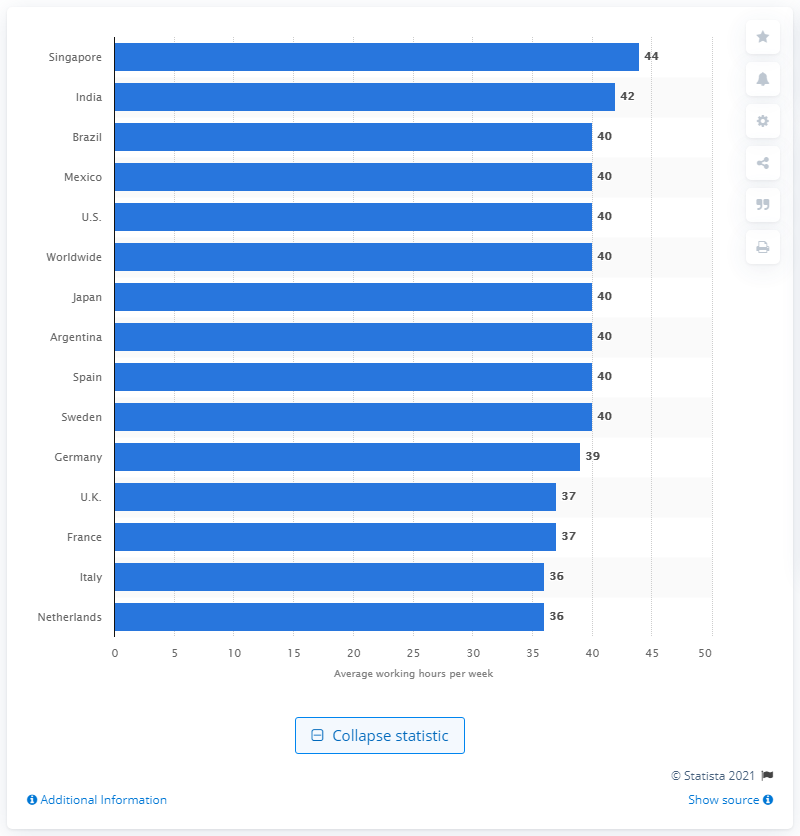Indicate a few pertinent items in this graphic. The results indicate that the average number of hours worked per week by respondents from India is 42 hours. 